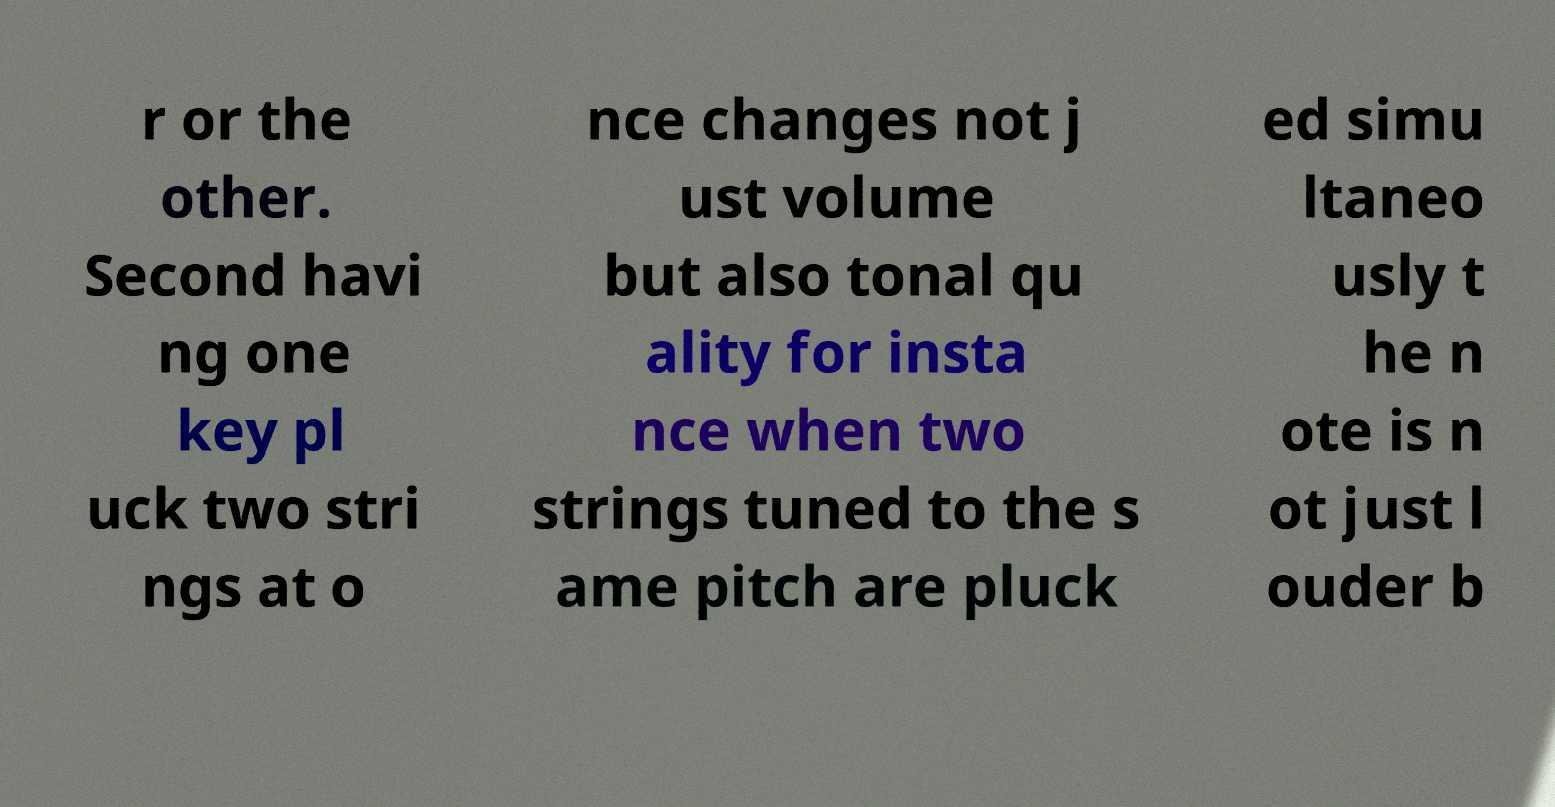For documentation purposes, I need the text within this image transcribed. Could you provide that? r or the other. Second havi ng one key pl uck two stri ngs at o nce changes not j ust volume but also tonal qu ality for insta nce when two strings tuned to the s ame pitch are pluck ed simu ltaneo usly t he n ote is n ot just l ouder b 